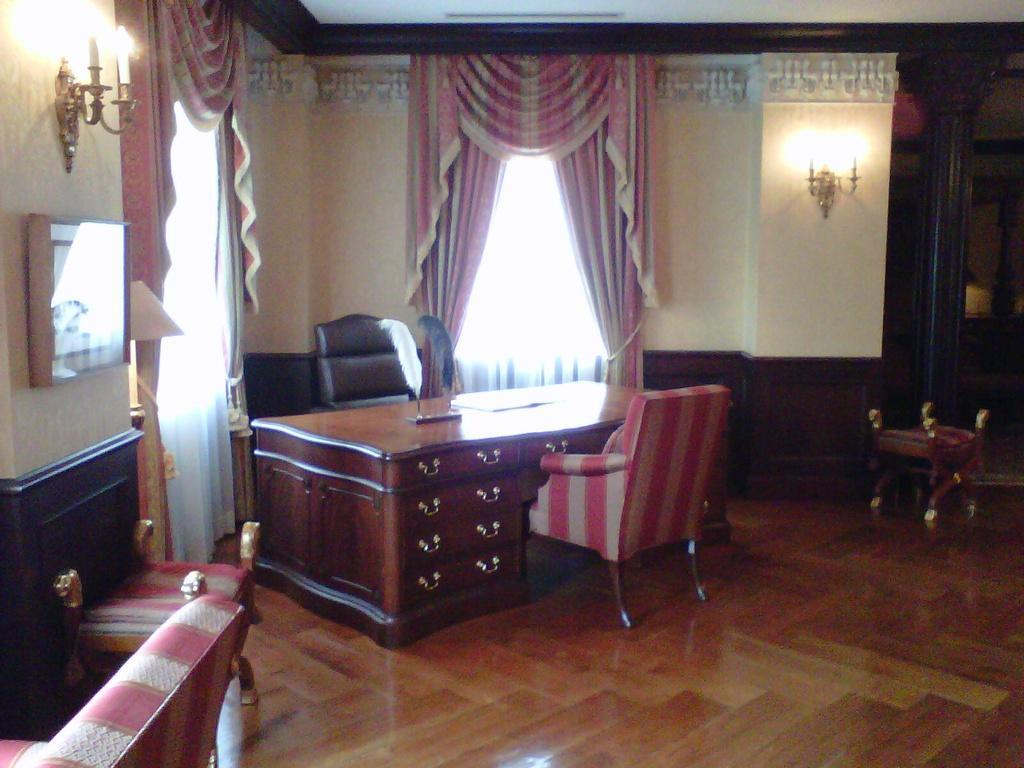Describe this image in one or two sentences. Here near the table there are two chairs ,lamp,on the wall there are curtains,here there is window. 